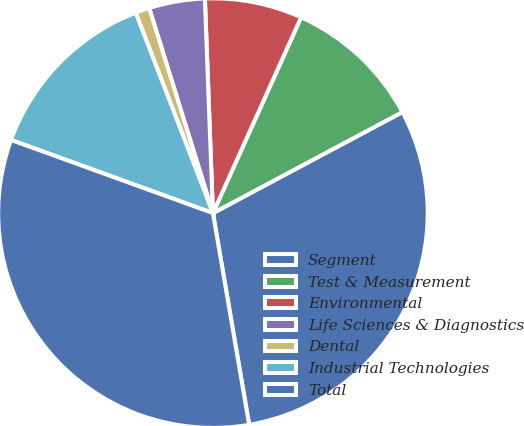<chart> <loc_0><loc_0><loc_500><loc_500><pie_chart><fcel>Segment<fcel>Test & Measurement<fcel>Environmental<fcel>Life Sciences & Diagnostics<fcel>Dental<fcel>Industrial Technologies<fcel>Total<nl><fcel>30.1%<fcel>10.47%<fcel>7.33%<fcel>4.2%<fcel>1.06%<fcel>13.61%<fcel>33.23%<nl></chart> 